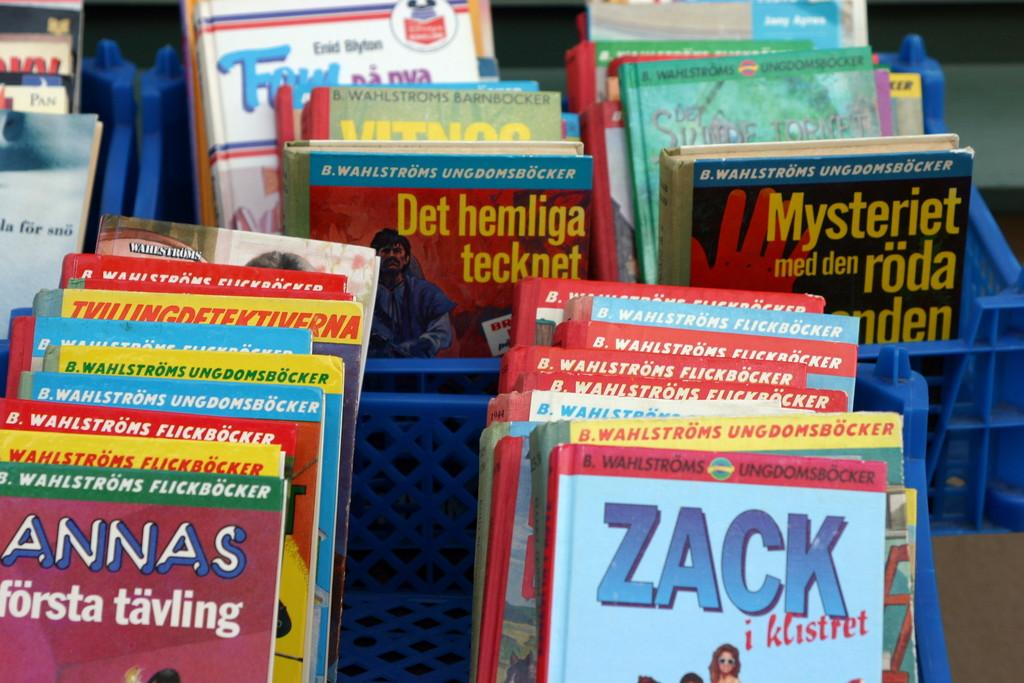<image>
Share a concise interpretation of the image provided. A variety of books in stacks in boxes with one named Zack towards the front. 